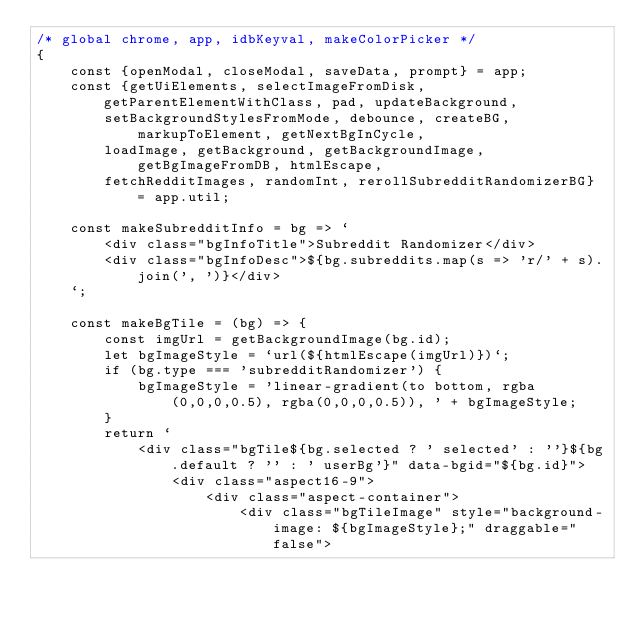Convert code to text. <code><loc_0><loc_0><loc_500><loc_500><_JavaScript_>/* global chrome, app, idbKeyval, makeColorPicker */
{
    const {openModal, closeModal, saveData, prompt} = app;
    const {getUiElements, selectImageFromDisk, getParentElementWithClass, pad, updateBackground,
        setBackgroundStylesFromMode, debounce, createBG, markupToElement, getNextBgInCycle,
        loadImage, getBackground, getBackgroundImage, getBgImageFromDB, htmlEscape,
        fetchRedditImages, randomInt, rerollSubredditRandomizerBG} = app.util;

    const makeSubredditInfo = bg => `
        <div class="bgInfoTitle">Subreddit Randomizer</div>
        <div class="bgInfoDesc">${bg.subreddits.map(s => 'r/' + s).join(', ')}</div>
    `;

    const makeBgTile = (bg) => {
        const imgUrl = getBackgroundImage(bg.id);
        let bgImageStyle = `url(${htmlEscape(imgUrl)})`;
        if (bg.type === 'subredditRandomizer') {
            bgImageStyle = 'linear-gradient(to bottom, rgba(0,0,0,0.5), rgba(0,0,0,0.5)), ' + bgImageStyle;
        }
        return `
            <div class="bgTile${bg.selected ? ' selected' : ''}${bg.default ? '' : ' userBg'}" data-bgid="${bg.id}">
                <div class="aspect16-9">
                    <div class="aspect-container">
                        <div class="bgTileImage" style="background-image: ${bgImageStyle};" draggable="false"></code> 